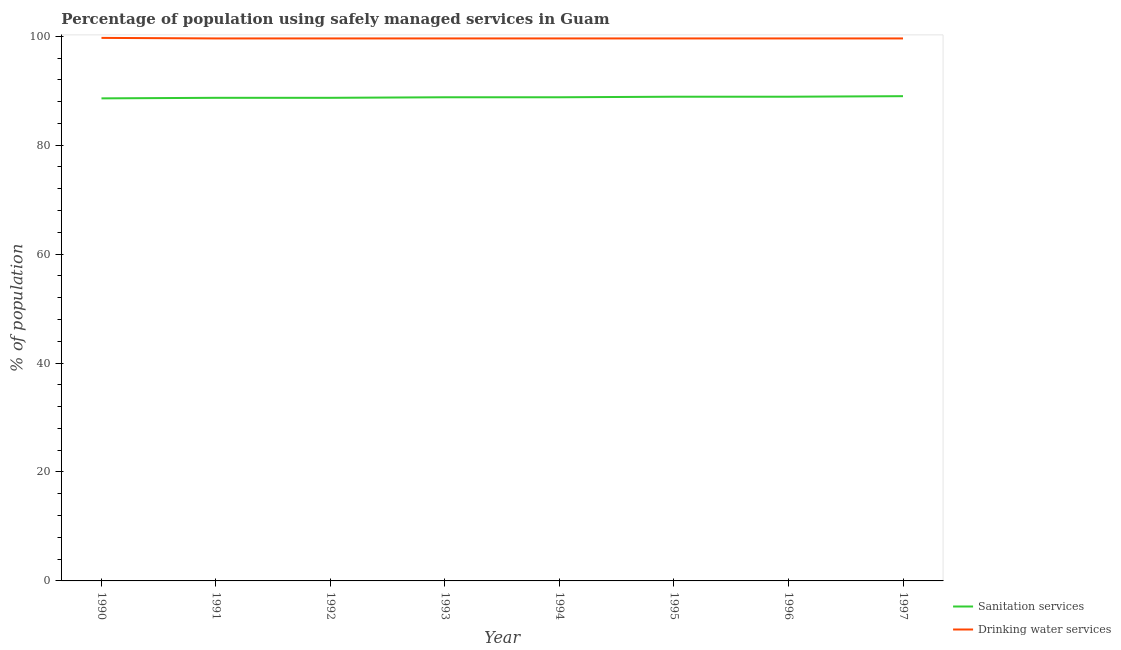Is the number of lines equal to the number of legend labels?
Provide a succinct answer. Yes. What is the percentage of population who used sanitation services in 1990?
Provide a short and direct response. 88.6. Across all years, what is the maximum percentage of population who used drinking water services?
Provide a short and direct response. 99.7. Across all years, what is the minimum percentage of population who used sanitation services?
Give a very brief answer. 88.6. What is the total percentage of population who used sanitation services in the graph?
Your answer should be compact. 710.4. What is the difference between the percentage of population who used sanitation services in 1993 and that in 1996?
Offer a terse response. -0.1. What is the difference between the percentage of population who used sanitation services in 1992 and the percentage of population who used drinking water services in 1994?
Provide a short and direct response. -10.9. What is the average percentage of population who used sanitation services per year?
Make the answer very short. 88.8. In the year 1990, what is the difference between the percentage of population who used drinking water services and percentage of population who used sanitation services?
Keep it short and to the point. 11.1. What is the ratio of the percentage of population who used drinking water services in 1990 to that in 1997?
Offer a very short reply. 1. Is the percentage of population who used drinking water services in 1990 less than that in 1993?
Provide a succinct answer. No. Is the difference between the percentage of population who used sanitation services in 1991 and 1995 greater than the difference between the percentage of population who used drinking water services in 1991 and 1995?
Ensure brevity in your answer.  No. What is the difference between the highest and the second highest percentage of population who used sanitation services?
Your answer should be very brief. 0.1. What is the difference between the highest and the lowest percentage of population who used sanitation services?
Keep it short and to the point. 0.4. In how many years, is the percentage of population who used drinking water services greater than the average percentage of population who used drinking water services taken over all years?
Your answer should be compact. 1. Does the percentage of population who used sanitation services monotonically increase over the years?
Keep it short and to the point. No. How many lines are there?
Give a very brief answer. 2. Are the values on the major ticks of Y-axis written in scientific E-notation?
Give a very brief answer. No. Where does the legend appear in the graph?
Provide a short and direct response. Bottom right. How are the legend labels stacked?
Provide a succinct answer. Vertical. What is the title of the graph?
Make the answer very short. Percentage of population using safely managed services in Guam. What is the label or title of the Y-axis?
Offer a very short reply. % of population. What is the % of population in Sanitation services in 1990?
Ensure brevity in your answer.  88.6. What is the % of population in Drinking water services in 1990?
Provide a succinct answer. 99.7. What is the % of population in Sanitation services in 1991?
Offer a very short reply. 88.7. What is the % of population in Drinking water services in 1991?
Provide a succinct answer. 99.6. What is the % of population in Sanitation services in 1992?
Give a very brief answer. 88.7. What is the % of population of Drinking water services in 1992?
Your answer should be compact. 99.6. What is the % of population in Sanitation services in 1993?
Ensure brevity in your answer.  88.8. What is the % of population in Drinking water services in 1993?
Your response must be concise. 99.6. What is the % of population of Sanitation services in 1994?
Make the answer very short. 88.8. What is the % of population in Drinking water services in 1994?
Provide a succinct answer. 99.6. What is the % of population in Sanitation services in 1995?
Give a very brief answer. 88.9. What is the % of population of Drinking water services in 1995?
Keep it short and to the point. 99.6. What is the % of population of Sanitation services in 1996?
Offer a very short reply. 88.9. What is the % of population of Drinking water services in 1996?
Provide a short and direct response. 99.6. What is the % of population of Sanitation services in 1997?
Keep it short and to the point. 89. What is the % of population in Drinking water services in 1997?
Provide a succinct answer. 99.6. Across all years, what is the maximum % of population of Sanitation services?
Offer a terse response. 89. Across all years, what is the maximum % of population in Drinking water services?
Make the answer very short. 99.7. Across all years, what is the minimum % of population in Sanitation services?
Your response must be concise. 88.6. Across all years, what is the minimum % of population of Drinking water services?
Ensure brevity in your answer.  99.6. What is the total % of population in Sanitation services in the graph?
Your answer should be compact. 710.4. What is the total % of population of Drinking water services in the graph?
Your response must be concise. 796.9. What is the difference between the % of population in Sanitation services in 1990 and that in 1991?
Give a very brief answer. -0.1. What is the difference between the % of population in Drinking water services in 1990 and that in 1991?
Provide a short and direct response. 0.1. What is the difference between the % of population of Drinking water services in 1990 and that in 1992?
Provide a short and direct response. 0.1. What is the difference between the % of population in Sanitation services in 1990 and that in 1993?
Offer a very short reply. -0.2. What is the difference between the % of population in Sanitation services in 1990 and that in 1994?
Offer a terse response. -0.2. What is the difference between the % of population in Drinking water services in 1990 and that in 1994?
Make the answer very short. 0.1. What is the difference between the % of population in Drinking water services in 1990 and that in 1995?
Keep it short and to the point. 0.1. What is the difference between the % of population in Sanitation services in 1990 and that in 1996?
Offer a terse response. -0.3. What is the difference between the % of population of Drinking water services in 1990 and that in 1996?
Provide a short and direct response. 0.1. What is the difference between the % of population in Sanitation services in 1990 and that in 1997?
Provide a short and direct response. -0.4. What is the difference between the % of population in Drinking water services in 1991 and that in 1992?
Make the answer very short. 0. What is the difference between the % of population in Sanitation services in 1991 and that in 1993?
Provide a short and direct response. -0.1. What is the difference between the % of population in Drinking water services in 1991 and that in 1993?
Keep it short and to the point. 0. What is the difference between the % of population of Drinking water services in 1991 and that in 1994?
Offer a very short reply. 0. What is the difference between the % of population in Drinking water services in 1991 and that in 1995?
Provide a short and direct response. 0. What is the difference between the % of population of Drinking water services in 1991 and that in 1997?
Your answer should be compact. 0. What is the difference between the % of population of Drinking water services in 1992 and that in 1993?
Offer a terse response. 0. What is the difference between the % of population in Drinking water services in 1992 and that in 1995?
Make the answer very short. 0. What is the difference between the % of population of Sanitation services in 1992 and that in 1997?
Offer a terse response. -0.3. What is the difference between the % of population in Drinking water services in 1992 and that in 1997?
Your response must be concise. 0. What is the difference between the % of population of Sanitation services in 1993 and that in 1994?
Your response must be concise. 0. What is the difference between the % of population in Drinking water services in 1993 and that in 1994?
Provide a short and direct response. 0. What is the difference between the % of population of Sanitation services in 1993 and that in 1996?
Your answer should be very brief. -0.1. What is the difference between the % of population of Drinking water services in 1993 and that in 1996?
Offer a very short reply. 0. What is the difference between the % of population in Drinking water services in 1993 and that in 1997?
Your answer should be compact. 0. What is the difference between the % of population in Sanitation services in 1994 and that in 1995?
Provide a short and direct response. -0.1. What is the difference between the % of population of Sanitation services in 1995 and that in 1997?
Keep it short and to the point. -0.1. What is the difference between the % of population in Drinking water services in 1995 and that in 1997?
Ensure brevity in your answer.  0. What is the difference between the % of population in Sanitation services in 1996 and that in 1997?
Provide a short and direct response. -0.1. What is the difference between the % of population of Drinking water services in 1996 and that in 1997?
Provide a succinct answer. 0. What is the difference between the % of population in Sanitation services in 1990 and the % of population in Drinking water services in 1993?
Keep it short and to the point. -11. What is the difference between the % of population in Sanitation services in 1990 and the % of population in Drinking water services in 1994?
Provide a succinct answer. -11. What is the difference between the % of population in Sanitation services in 1990 and the % of population in Drinking water services in 1995?
Give a very brief answer. -11. What is the difference between the % of population of Sanitation services in 1990 and the % of population of Drinking water services in 1996?
Your answer should be very brief. -11. What is the difference between the % of population in Sanitation services in 1991 and the % of population in Drinking water services in 1994?
Offer a terse response. -10.9. What is the difference between the % of population in Sanitation services in 1991 and the % of population in Drinking water services in 1995?
Your answer should be very brief. -10.9. What is the difference between the % of population in Sanitation services in 1991 and the % of population in Drinking water services in 1996?
Offer a very short reply. -10.9. What is the difference between the % of population in Sanitation services in 1991 and the % of population in Drinking water services in 1997?
Your response must be concise. -10.9. What is the difference between the % of population in Sanitation services in 1992 and the % of population in Drinking water services in 1993?
Give a very brief answer. -10.9. What is the difference between the % of population in Sanitation services in 1992 and the % of population in Drinking water services in 1994?
Offer a very short reply. -10.9. What is the difference between the % of population in Sanitation services in 1992 and the % of population in Drinking water services in 1995?
Make the answer very short. -10.9. What is the difference between the % of population in Sanitation services in 1993 and the % of population in Drinking water services in 1994?
Your response must be concise. -10.8. What is the difference between the % of population of Sanitation services in 1993 and the % of population of Drinking water services in 1995?
Your response must be concise. -10.8. What is the difference between the % of population in Sanitation services in 1993 and the % of population in Drinking water services in 1997?
Offer a very short reply. -10.8. What is the average % of population of Sanitation services per year?
Ensure brevity in your answer.  88.8. What is the average % of population of Drinking water services per year?
Offer a very short reply. 99.61. In the year 1991, what is the difference between the % of population in Sanitation services and % of population in Drinking water services?
Make the answer very short. -10.9. In the year 1996, what is the difference between the % of population of Sanitation services and % of population of Drinking water services?
Keep it short and to the point. -10.7. In the year 1997, what is the difference between the % of population in Sanitation services and % of population in Drinking water services?
Keep it short and to the point. -10.6. What is the ratio of the % of population in Sanitation services in 1990 to that in 1991?
Offer a terse response. 1. What is the ratio of the % of population of Drinking water services in 1990 to that in 1991?
Make the answer very short. 1. What is the ratio of the % of population in Sanitation services in 1990 to that in 1993?
Provide a short and direct response. 1. What is the ratio of the % of population in Drinking water services in 1990 to that in 1993?
Provide a succinct answer. 1. What is the ratio of the % of population of Drinking water services in 1990 to that in 1994?
Your answer should be compact. 1. What is the ratio of the % of population of Sanitation services in 1990 to that in 1995?
Ensure brevity in your answer.  1. What is the ratio of the % of population in Drinking water services in 1990 to that in 1996?
Provide a short and direct response. 1. What is the ratio of the % of population in Drinking water services in 1991 to that in 1993?
Offer a terse response. 1. What is the ratio of the % of population in Drinking water services in 1991 to that in 1995?
Make the answer very short. 1. What is the ratio of the % of population of Drinking water services in 1991 to that in 1996?
Your answer should be very brief. 1. What is the ratio of the % of population in Drinking water services in 1991 to that in 1997?
Provide a short and direct response. 1. What is the ratio of the % of population in Drinking water services in 1992 to that in 1994?
Provide a succinct answer. 1. What is the ratio of the % of population of Sanitation services in 1992 to that in 1995?
Your answer should be compact. 1. What is the ratio of the % of population of Drinking water services in 1992 to that in 1995?
Provide a short and direct response. 1. What is the ratio of the % of population in Sanitation services in 1992 to that in 1996?
Make the answer very short. 1. What is the ratio of the % of population of Drinking water services in 1992 to that in 1996?
Ensure brevity in your answer.  1. What is the ratio of the % of population in Sanitation services in 1992 to that in 1997?
Make the answer very short. 1. What is the ratio of the % of population of Drinking water services in 1992 to that in 1997?
Your answer should be very brief. 1. What is the ratio of the % of population in Sanitation services in 1993 to that in 1994?
Your answer should be very brief. 1. What is the ratio of the % of population of Drinking water services in 1993 to that in 1994?
Your response must be concise. 1. What is the ratio of the % of population of Drinking water services in 1993 to that in 1995?
Ensure brevity in your answer.  1. What is the ratio of the % of population in Sanitation services in 1993 to that in 1996?
Keep it short and to the point. 1. What is the ratio of the % of population of Sanitation services in 1993 to that in 1997?
Provide a short and direct response. 1. What is the ratio of the % of population of Drinking water services in 1993 to that in 1997?
Offer a terse response. 1. What is the ratio of the % of population of Drinking water services in 1994 to that in 1995?
Make the answer very short. 1. What is the ratio of the % of population in Sanitation services in 1994 to that in 1997?
Your answer should be very brief. 1. What is the ratio of the % of population in Drinking water services in 1994 to that in 1997?
Offer a terse response. 1. What is the ratio of the % of population in Sanitation services in 1995 to that in 1996?
Provide a succinct answer. 1. What is the ratio of the % of population in Drinking water services in 1995 to that in 1997?
Offer a terse response. 1. What is the ratio of the % of population of Drinking water services in 1996 to that in 1997?
Keep it short and to the point. 1. What is the difference between the highest and the second highest % of population of Drinking water services?
Ensure brevity in your answer.  0.1. What is the difference between the highest and the lowest % of population of Sanitation services?
Your answer should be very brief. 0.4. What is the difference between the highest and the lowest % of population of Drinking water services?
Keep it short and to the point. 0.1. 